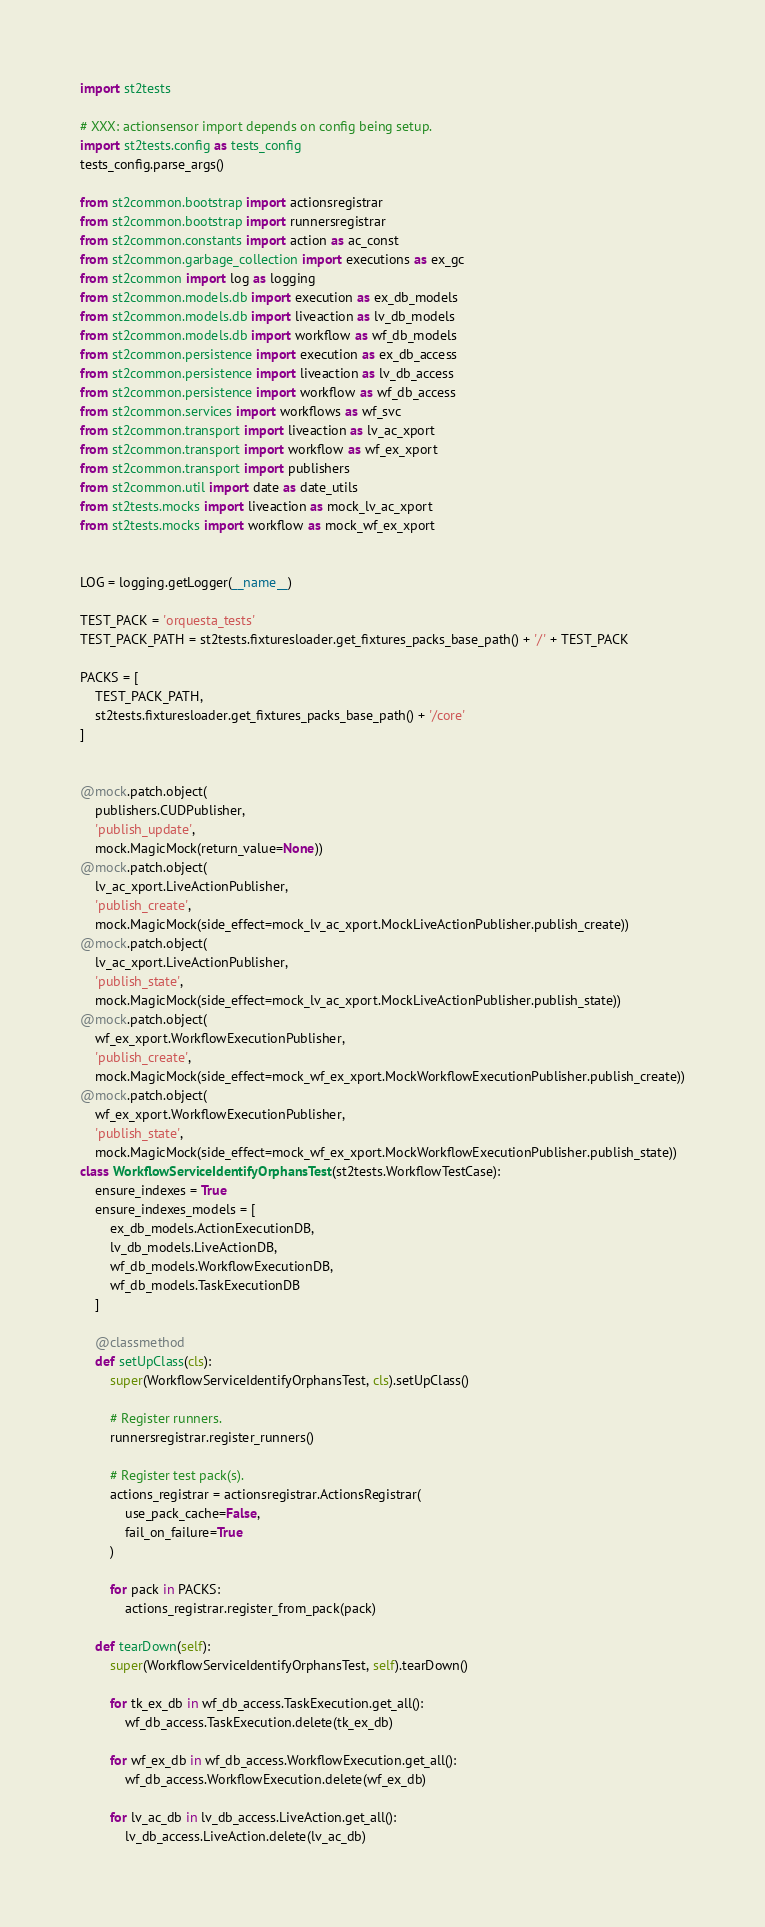Convert code to text. <code><loc_0><loc_0><loc_500><loc_500><_Python_>
import st2tests

# XXX: actionsensor import depends on config being setup.
import st2tests.config as tests_config
tests_config.parse_args()

from st2common.bootstrap import actionsregistrar
from st2common.bootstrap import runnersregistrar
from st2common.constants import action as ac_const
from st2common.garbage_collection import executions as ex_gc
from st2common import log as logging
from st2common.models.db import execution as ex_db_models
from st2common.models.db import liveaction as lv_db_models
from st2common.models.db import workflow as wf_db_models
from st2common.persistence import execution as ex_db_access
from st2common.persistence import liveaction as lv_db_access
from st2common.persistence import workflow as wf_db_access
from st2common.services import workflows as wf_svc
from st2common.transport import liveaction as lv_ac_xport
from st2common.transport import workflow as wf_ex_xport
from st2common.transport import publishers
from st2common.util import date as date_utils
from st2tests.mocks import liveaction as mock_lv_ac_xport
from st2tests.mocks import workflow as mock_wf_ex_xport


LOG = logging.getLogger(__name__)

TEST_PACK = 'orquesta_tests'
TEST_PACK_PATH = st2tests.fixturesloader.get_fixtures_packs_base_path() + '/' + TEST_PACK

PACKS = [
    TEST_PACK_PATH,
    st2tests.fixturesloader.get_fixtures_packs_base_path() + '/core'
]


@mock.patch.object(
    publishers.CUDPublisher,
    'publish_update',
    mock.MagicMock(return_value=None))
@mock.patch.object(
    lv_ac_xport.LiveActionPublisher,
    'publish_create',
    mock.MagicMock(side_effect=mock_lv_ac_xport.MockLiveActionPublisher.publish_create))
@mock.patch.object(
    lv_ac_xport.LiveActionPublisher,
    'publish_state',
    mock.MagicMock(side_effect=mock_lv_ac_xport.MockLiveActionPublisher.publish_state))
@mock.patch.object(
    wf_ex_xport.WorkflowExecutionPublisher,
    'publish_create',
    mock.MagicMock(side_effect=mock_wf_ex_xport.MockWorkflowExecutionPublisher.publish_create))
@mock.patch.object(
    wf_ex_xport.WorkflowExecutionPublisher,
    'publish_state',
    mock.MagicMock(side_effect=mock_wf_ex_xport.MockWorkflowExecutionPublisher.publish_state))
class WorkflowServiceIdentifyOrphansTest(st2tests.WorkflowTestCase):
    ensure_indexes = True
    ensure_indexes_models = [
        ex_db_models.ActionExecutionDB,
        lv_db_models.LiveActionDB,
        wf_db_models.WorkflowExecutionDB,
        wf_db_models.TaskExecutionDB
    ]

    @classmethod
    def setUpClass(cls):
        super(WorkflowServiceIdentifyOrphansTest, cls).setUpClass()

        # Register runners.
        runnersregistrar.register_runners()

        # Register test pack(s).
        actions_registrar = actionsregistrar.ActionsRegistrar(
            use_pack_cache=False,
            fail_on_failure=True
        )

        for pack in PACKS:
            actions_registrar.register_from_pack(pack)

    def tearDown(self):
        super(WorkflowServiceIdentifyOrphansTest, self).tearDown()

        for tk_ex_db in wf_db_access.TaskExecution.get_all():
            wf_db_access.TaskExecution.delete(tk_ex_db)

        for wf_ex_db in wf_db_access.WorkflowExecution.get_all():
            wf_db_access.WorkflowExecution.delete(wf_ex_db)

        for lv_ac_db in lv_db_access.LiveAction.get_all():
            lv_db_access.LiveAction.delete(lv_ac_db)
</code> 